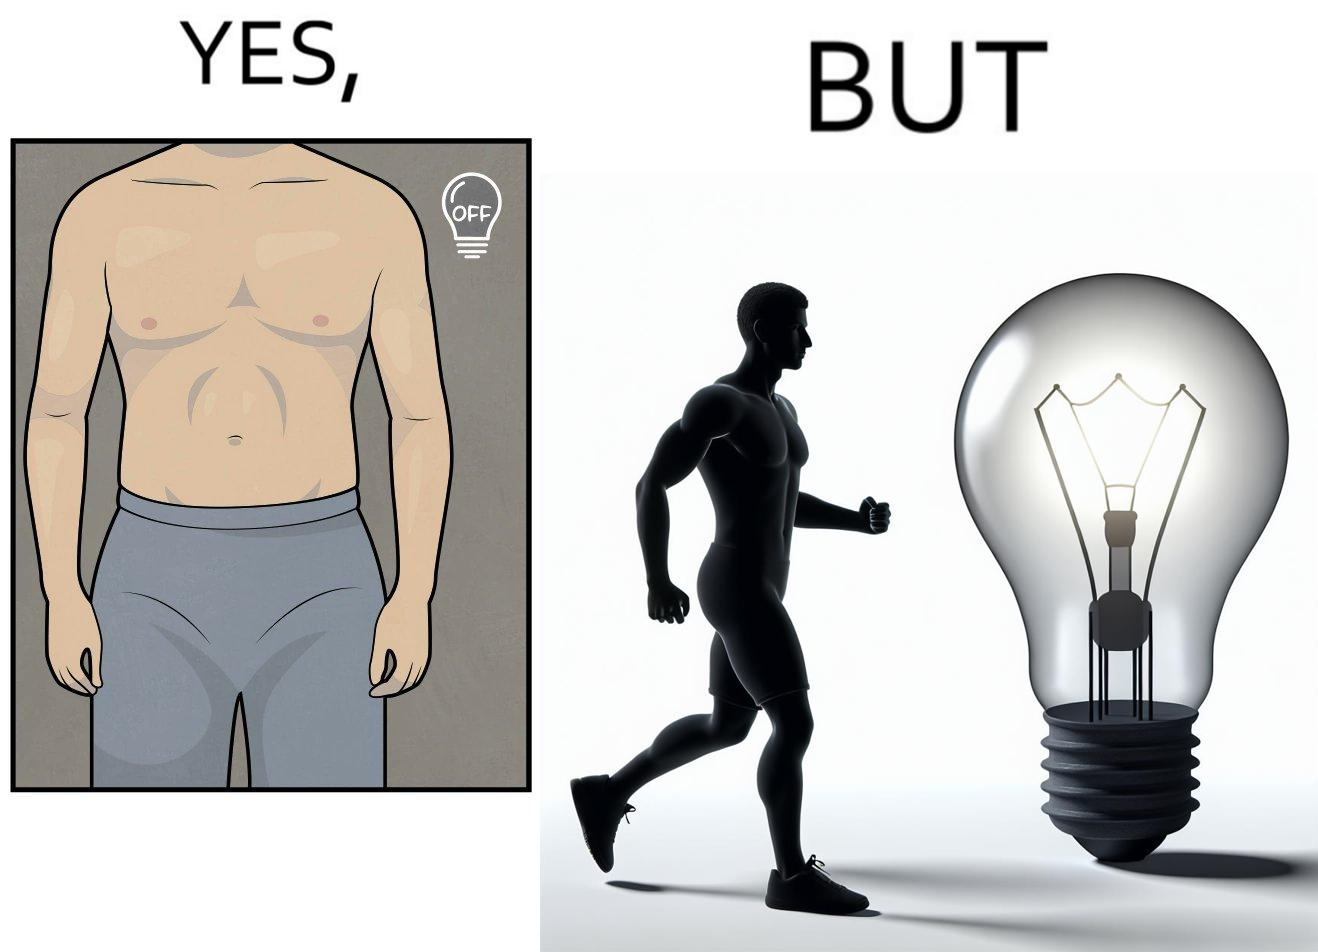Explain the humor or irony in this image. The images are funny because it shows the same body in two different lighting conditions, one where it appears muscular and one where it does not appear so. It shows how we can make the same thing appear appealing to others without it being as appealing in real life 